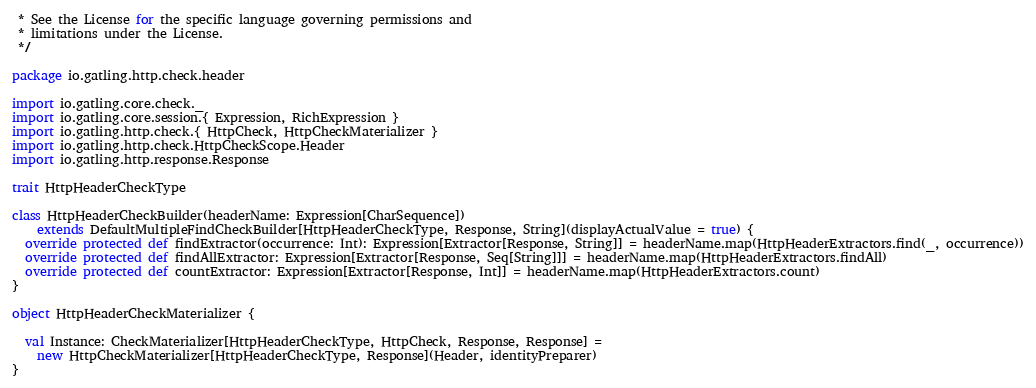<code> <loc_0><loc_0><loc_500><loc_500><_Scala_> * See the License for the specific language governing permissions and
 * limitations under the License.
 */

package io.gatling.http.check.header

import io.gatling.core.check._
import io.gatling.core.session.{ Expression, RichExpression }
import io.gatling.http.check.{ HttpCheck, HttpCheckMaterializer }
import io.gatling.http.check.HttpCheckScope.Header
import io.gatling.http.response.Response

trait HttpHeaderCheckType

class HttpHeaderCheckBuilder(headerName: Expression[CharSequence])
    extends DefaultMultipleFindCheckBuilder[HttpHeaderCheckType, Response, String](displayActualValue = true) {
  override protected def findExtractor(occurrence: Int): Expression[Extractor[Response, String]] = headerName.map(HttpHeaderExtractors.find(_, occurrence))
  override protected def findAllExtractor: Expression[Extractor[Response, Seq[String]]] = headerName.map(HttpHeaderExtractors.findAll)
  override protected def countExtractor: Expression[Extractor[Response, Int]] = headerName.map(HttpHeaderExtractors.count)
}

object HttpHeaderCheckMaterializer {

  val Instance: CheckMaterializer[HttpHeaderCheckType, HttpCheck, Response, Response] =
    new HttpCheckMaterializer[HttpHeaderCheckType, Response](Header, identityPreparer)
}
</code> 